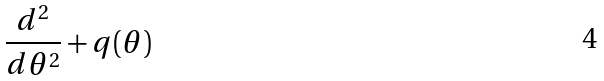<formula> <loc_0><loc_0><loc_500><loc_500>\frac { d ^ { 2 } } { d \theta ^ { 2 } } + q ( \theta )</formula> 